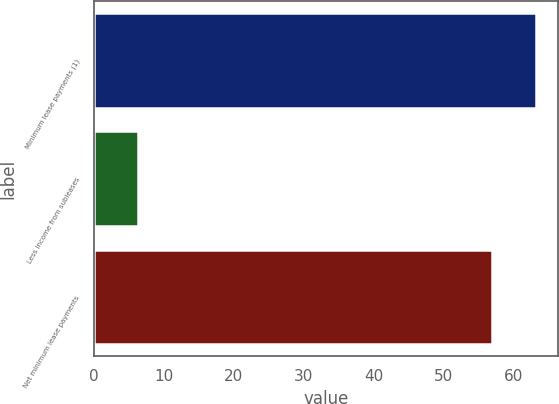Convert chart to OTSL. <chart><loc_0><loc_0><loc_500><loc_500><bar_chart><fcel>Minimum lease payments (1)<fcel>Less income from subleases<fcel>Net minimum lease payments<nl><fcel>63.2<fcel>6.3<fcel>56.9<nl></chart> 